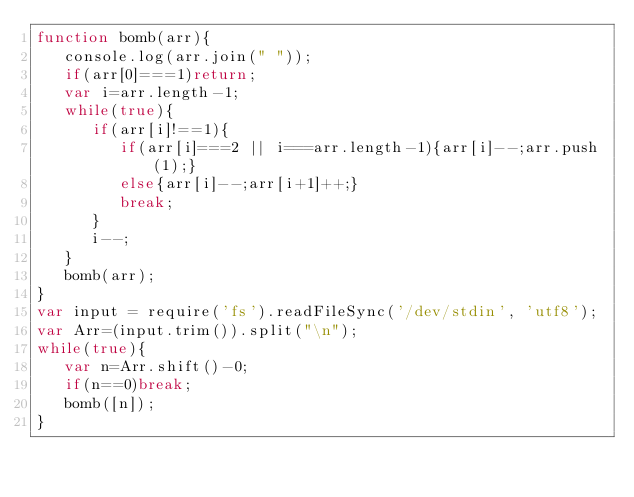<code> <loc_0><loc_0><loc_500><loc_500><_JavaScript_>function bomb(arr){
   console.log(arr.join(" "));
   if(arr[0]===1)return;
   var i=arr.length-1;
   while(true){
      if(arr[i]!==1){
         if(arr[i]===2 || i===arr.length-1){arr[i]--;arr.push(1);}
         else{arr[i]--;arr[i+1]++;}
         break;
      }
      i--;
   }
   bomb(arr);
}
var input = require('fs').readFileSync('/dev/stdin', 'utf8');
var Arr=(input.trim()).split("\n");
while(true){
   var n=Arr.shift()-0;
   if(n==0)break;
   bomb([n]);
}</code> 